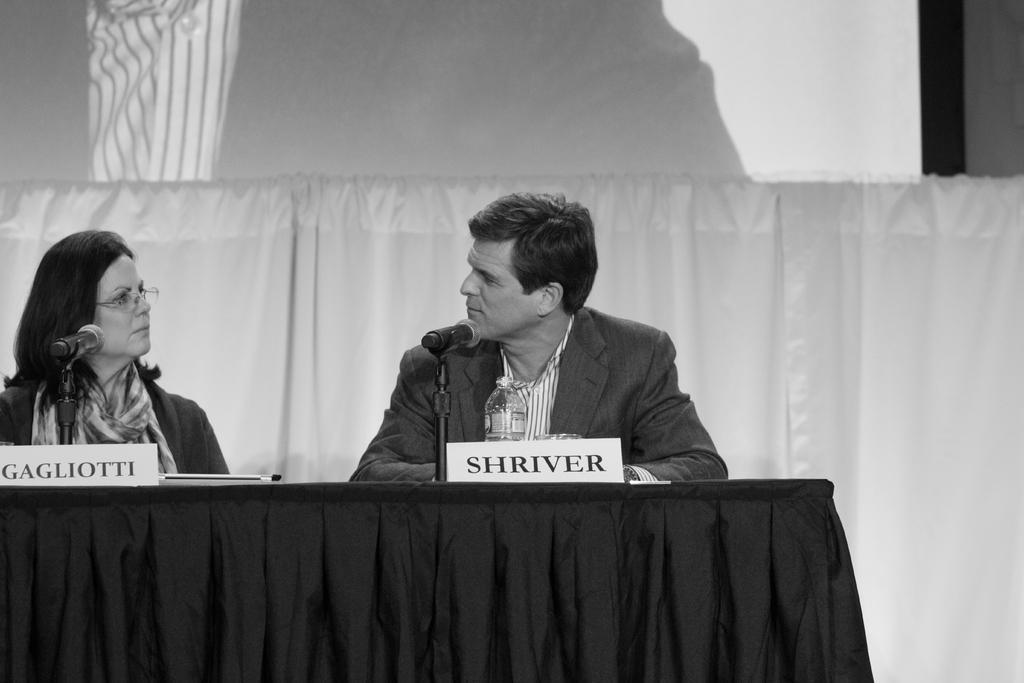Can you describe this image briefly? In this image there are two people a woman and a man. In the left side of the image a woman is sitting on the chair. In the middle of the image a man is sitting on the chair placing his hands on the table. In the middle of the image there is a table with table cloth on it and there is a name board, mic and a water bottle and a glass with water are there on it. In the background there is a projector screen and curtains. 